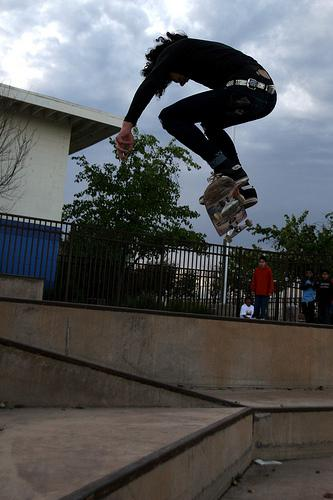Question: how is the skateboarder positioned?
Choices:
A. In midair.
B. On the ramp.
C. On the ground.
D. Falling.
Answer with the letter. Answer: A Question: when was the photo taken?
Choices:
A. Morning.
B. Dusk.
C. On a cloudy day.
D. Nighttime.
Answer with the letter. Answer: C Question: who is watching in the background?
Choices:
A. The neighbors.
B. Kids.
C. The parents.
D. The horses.
Answer with the letter. Answer: B Question: where is the skateboard?
Choices:
A. In his back pack.
B. In the air.
C. On the ground.
D. On the picnic table.
Answer with the letter. Answer: B Question: what horizontal metal object is shown?
Choices:
A. A black fence.
B. A bench.
C. A pole.
D. A rail.
Answer with the letter. Answer: A Question: why are the kids watching?
Choices:
A. To be amazed.
B. To learn tricks.
C. To watch somebody crash.
D. To be amused.
Answer with the letter. Answer: B 